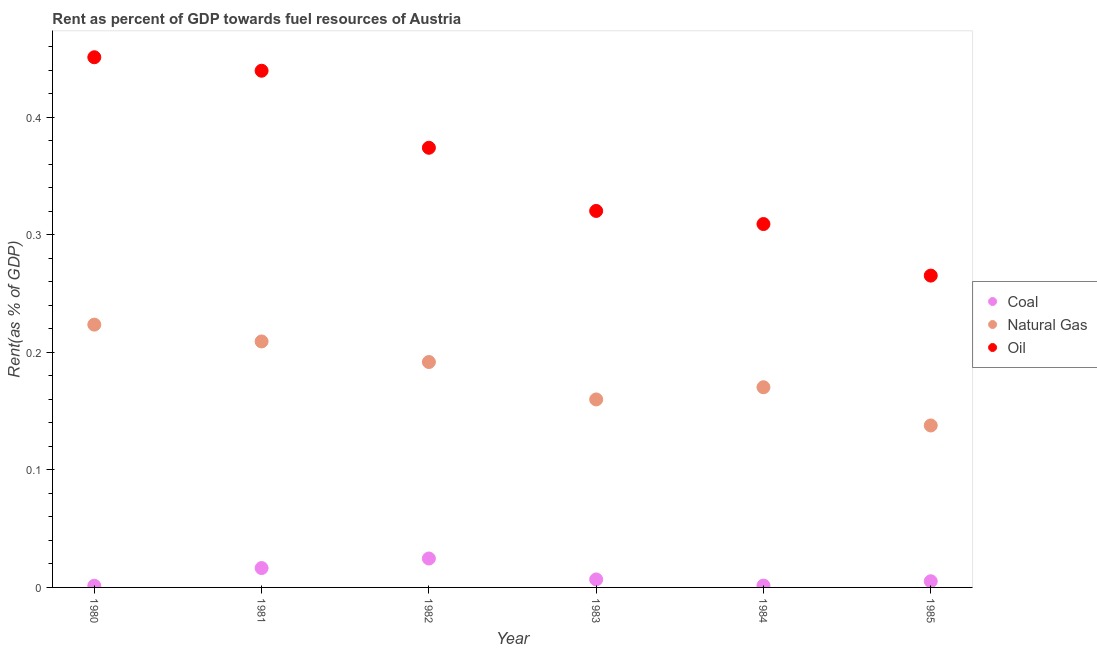How many different coloured dotlines are there?
Your answer should be compact. 3. What is the rent towards natural gas in 1981?
Make the answer very short. 0.21. Across all years, what is the maximum rent towards coal?
Offer a terse response. 0.02. Across all years, what is the minimum rent towards oil?
Your answer should be very brief. 0.27. In which year was the rent towards natural gas maximum?
Provide a succinct answer. 1980. In which year was the rent towards oil minimum?
Keep it short and to the point. 1985. What is the total rent towards oil in the graph?
Give a very brief answer. 2.16. What is the difference between the rent towards coal in 1980 and that in 1981?
Keep it short and to the point. -0.02. What is the difference between the rent towards oil in 1983 and the rent towards natural gas in 1984?
Offer a terse response. 0.15. What is the average rent towards natural gas per year?
Your response must be concise. 0.18. In the year 1985, what is the difference between the rent towards coal and rent towards natural gas?
Provide a succinct answer. -0.13. In how many years, is the rent towards coal greater than 0.1 %?
Your answer should be compact. 0. What is the ratio of the rent towards coal in 1984 to that in 1985?
Ensure brevity in your answer.  0.29. What is the difference between the highest and the second highest rent towards coal?
Your answer should be compact. 0.01. What is the difference between the highest and the lowest rent towards coal?
Make the answer very short. 0.02. In how many years, is the rent towards natural gas greater than the average rent towards natural gas taken over all years?
Your answer should be very brief. 3. Is the sum of the rent towards oil in 1980 and 1983 greater than the maximum rent towards coal across all years?
Make the answer very short. Yes. Is it the case that in every year, the sum of the rent towards coal and rent towards natural gas is greater than the rent towards oil?
Provide a short and direct response. No. Is the rent towards coal strictly greater than the rent towards oil over the years?
Provide a succinct answer. No. How many dotlines are there?
Offer a very short reply. 3. What is the difference between two consecutive major ticks on the Y-axis?
Your response must be concise. 0.1. Are the values on the major ticks of Y-axis written in scientific E-notation?
Your answer should be very brief. No. Where does the legend appear in the graph?
Make the answer very short. Center right. How are the legend labels stacked?
Your response must be concise. Vertical. What is the title of the graph?
Your answer should be compact. Rent as percent of GDP towards fuel resources of Austria. Does "Travel services" appear as one of the legend labels in the graph?
Offer a terse response. No. What is the label or title of the Y-axis?
Keep it short and to the point. Rent(as % of GDP). What is the Rent(as % of GDP) in Coal in 1980?
Make the answer very short. 0. What is the Rent(as % of GDP) in Natural Gas in 1980?
Your response must be concise. 0.22. What is the Rent(as % of GDP) of Oil in 1980?
Ensure brevity in your answer.  0.45. What is the Rent(as % of GDP) of Coal in 1981?
Keep it short and to the point. 0.02. What is the Rent(as % of GDP) in Natural Gas in 1981?
Keep it short and to the point. 0.21. What is the Rent(as % of GDP) in Oil in 1981?
Provide a succinct answer. 0.44. What is the Rent(as % of GDP) in Coal in 1982?
Your answer should be compact. 0.02. What is the Rent(as % of GDP) of Natural Gas in 1982?
Your answer should be compact. 0.19. What is the Rent(as % of GDP) in Oil in 1982?
Keep it short and to the point. 0.37. What is the Rent(as % of GDP) of Coal in 1983?
Make the answer very short. 0.01. What is the Rent(as % of GDP) in Natural Gas in 1983?
Give a very brief answer. 0.16. What is the Rent(as % of GDP) in Oil in 1983?
Provide a short and direct response. 0.32. What is the Rent(as % of GDP) of Coal in 1984?
Give a very brief answer. 0. What is the Rent(as % of GDP) in Natural Gas in 1984?
Offer a very short reply. 0.17. What is the Rent(as % of GDP) of Oil in 1984?
Keep it short and to the point. 0.31. What is the Rent(as % of GDP) in Coal in 1985?
Offer a very short reply. 0.01. What is the Rent(as % of GDP) of Natural Gas in 1985?
Make the answer very short. 0.14. What is the Rent(as % of GDP) in Oil in 1985?
Provide a short and direct response. 0.27. Across all years, what is the maximum Rent(as % of GDP) in Coal?
Provide a succinct answer. 0.02. Across all years, what is the maximum Rent(as % of GDP) in Natural Gas?
Make the answer very short. 0.22. Across all years, what is the maximum Rent(as % of GDP) in Oil?
Your answer should be very brief. 0.45. Across all years, what is the minimum Rent(as % of GDP) of Coal?
Ensure brevity in your answer.  0. Across all years, what is the minimum Rent(as % of GDP) in Natural Gas?
Your answer should be compact. 0.14. Across all years, what is the minimum Rent(as % of GDP) in Oil?
Give a very brief answer. 0.27. What is the total Rent(as % of GDP) in Coal in the graph?
Provide a succinct answer. 0.06. What is the total Rent(as % of GDP) in Natural Gas in the graph?
Your answer should be very brief. 1.09. What is the total Rent(as % of GDP) of Oil in the graph?
Keep it short and to the point. 2.16. What is the difference between the Rent(as % of GDP) in Coal in 1980 and that in 1981?
Offer a very short reply. -0.02. What is the difference between the Rent(as % of GDP) in Natural Gas in 1980 and that in 1981?
Your response must be concise. 0.01. What is the difference between the Rent(as % of GDP) of Oil in 1980 and that in 1981?
Make the answer very short. 0.01. What is the difference between the Rent(as % of GDP) of Coal in 1980 and that in 1982?
Your response must be concise. -0.02. What is the difference between the Rent(as % of GDP) of Natural Gas in 1980 and that in 1982?
Your answer should be very brief. 0.03. What is the difference between the Rent(as % of GDP) in Oil in 1980 and that in 1982?
Provide a short and direct response. 0.08. What is the difference between the Rent(as % of GDP) of Coal in 1980 and that in 1983?
Provide a succinct answer. -0.01. What is the difference between the Rent(as % of GDP) in Natural Gas in 1980 and that in 1983?
Ensure brevity in your answer.  0.06. What is the difference between the Rent(as % of GDP) of Oil in 1980 and that in 1983?
Offer a very short reply. 0.13. What is the difference between the Rent(as % of GDP) of Coal in 1980 and that in 1984?
Provide a short and direct response. -0. What is the difference between the Rent(as % of GDP) in Natural Gas in 1980 and that in 1984?
Offer a terse response. 0.05. What is the difference between the Rent(as % of GDP) in Oil in 1980 and that in 1984?
Your answer should be very brief. 0.14. What is the difference between the Rent(as % of GDP) in Coal in 1980 and that in 1985?
Offer a very short reply. -0. What is the difference between the Rent(as % of GDP) of Natural Gas in 1980 and that in 1985?
Offer a very short reply. 0.09. What is the difference between the Rent(as % of GDP) of Oil in 1980 and that in 1985?
Your response must be concise. 0.19. What is the difference between the Rent(as % of GDP) of Coal in 1981 and that in 1982?
Ensure brevity in your answer.  -0.01. What is the difference between the Rent(as % of GDP) of Natural Gas in 1981 and that in 1982?
Your answer should be very brief. 0.02. What is the difference between the Rent(as % of GDP) of Oil in 1981 and that in 1982?
Your answer should be compact. 0.07. What is the difference between the Rent(as % of GDP) of Coal in 1981 and that in 1983?
Provide a succinct answer. 0.01. What is the difference between the Rent(as % of GDP) in Natural Gas in 1981 and that in 1983?
Offer a very short reply. 0.05. What is the difference between the Rent(as % of GDP) of Oil in 1981 and that in 1983?
Make the answer very short. 0.12. What is the difference between the Rent(as % of GDP) of Coal in 1981 and that in 1984?
Your response must be concise. 0.01. What is the difference between the Rent(as % of GDP) of Natural Gas in 1981 and that in 1984?
Ensure brevity in your answer.  0.04. What is the difference between the Rent(as % of GDP) in Oil in 1981 and that in 1984?
Offer a very short reply. 0.13. What is the difference between the Rent(as % of GDP) of Coal in 1981 and that in 1985?
Your answer should be compact. 0.01. What is the difference between the Rent(as % of GDP) in Natural Gas in 1981 and that in 1985?
Keep it short and to the point. 0.07. What is the difference between the Rent(as % of GDP) in Oil in 1981 and that in 1985?
Provide a succinct answer. 0.17. What is the difference between the Rent(as % of GDP) in Coal in 1982 and that in 1983?
Ensure brevity in your answer.  0.02. What is the difference between the Rent(as % of GDP) in Natural Gas in 1982 and that in 1983?
Ensure brevity in your answer.  0.03. What is the difference between the Rent(as % of GDP) of Oil in 1982 and that in 1983?
Offer a terse response. 0.05. What is the difference between the Rent(as % of GDP) of Coal in 1982 and that in 1984?
Offer a terse response. 0.02. What is the difference between the Rent(as % of GDP) of Natural Gas in 1982 and that in 1984?
Provide a short and direct response. 0.02. What is the difference between the Rent(as % of GDP) of Oil in 1982 and that in 1984?
Offer a terse response. 0.06. What is the difference between the Rent(as % of GDP) in Coal in 1982 and that in 1985?
Your answer should be compact. 0.02. What is the difference between the Rent(as % of GDP) in Natural Gas in 1982 and that in 1985?
Your answer should be very brief. 0.05. What is the difference between the Rent(as % of GDP) of Oil in 1982 and that in 1985?
Make the answer very short. 0.11. What is the difference between the Rent(as % of GDP) in Coal in 1983 and that in 1984?
Provide a short and direct response. 0.01. What is the difference between the Rent(as % of GDP) of Natural Gas in 1983 and that in 1984?
Keep it short and to the point. -0.01. What is the difference between the Rent(as % of GDP) in Oil in 1983 and that in 1984?
Give a very brief answer. 0.01. What is the difference between the Rent(as % of GDP) in Coal in 1983 and that in 1985?
Your answer should be very brief. 0. What is the difference between the Rent(as % of GDP) in Natural Gas in 1983 and that in 1985?
Your answer should be compact. 0.02. What is the difference between the Rent(as % of GDP) in Oil in 1983 and that in 1985?
Ensure brevity in your answer.  0.06. What is the difference between the Rent(as % of GDP) of Coal in 1984 and that in 1985?
Your response must be concise. -0. What is the difference between the Rent(as % of GDP) in Natural Gas in 1984 and that in 1985?
Your answer should be very brief. 0.03. What is the difference between the Rent(as % of GDP) in Oil in 1984 and that in 1985?
Your answer should be very brief. 0.04. What is the difference between the Rent(as % of GDP) in Coal in 1980 and the Rent(as % of GDP) in Natural Gas in 1981?
Provide a succinct answer. -0.21. What is the difference between the Rent(as % of GDP) in Coal in 1980 and the Rent(as % of GDP) in Oil in 1981?
Provide a short and direct response. -0.44. What is the difference between the Rent(as % of GDP) in Natural Gas in 1980 and the Rent(as % of GDP) in Oil in 1981?
Your answer should be very brief. -0.22. What is the difference between the Rent(as % of GDP) of Coal in 1980 and the Rent(as % of GDP) of Natural Gas in 1982?
Provide a short and direct response. -0.19. What is the difference between the Rent(as % of GDP) in Coal in 1980 and the Rent(as % of GDP) in Oil in 1982?
Offer a terse response. -0.37. What is the difference between the Rent(as % of GDP) in Natural Gas in 1980 and the Rent(as % of GDP) in Oil in 1982?
Your answer should be very brief. -0.15. What is the difference between the Rent(as % of GDP) of Coal in 1980 and the Rent(as % of GDP) of Natural Gas in 1983?
Offer a very short reply. -0.16. What is the difference between the Rent(as % of GDP) of Coal in 1980 and the Rent(as % of GDP) of Oil in 1983?
Ensure brevity in your answer.  -0.32. What is the difference between the Rent(as % of GDP) of Natural Gas in 1980 and the Rent(as % of GDP) of Oil in 1983?
Provide a succinct answer. -0.1. What is the difference between the Rent(as % of GDP) of Coal in 1980 and the Rent(as % of GDP) of Natural Gas in 1984?
Your answer should be compact. -0.17. What is the difference between the Rent(as % of GDP) of Coal in 1980 and the Rent(as % of GDP) of Oil in 1984?
Ensure brevity in your answer.  -0.31. What is the difference between the Rent(as % of GDP) in Natural Gas in 1980 and the Rent(as % of GDP) in Oil in 1984?
Provide a short and direct response. -0.09. What is the difference between the Rent(as % of GDP) of Coal in 1980 and the Rent(as % of GDP) of Natural Gas in 1985?
Provide a succinct answer. -0.14. What is the difference between the Rent(as % of GDP) in Coal in 1980 and the Rent(as % of GDP) in Oil in 1985?
Your response must be concise. -0.26. What is the difference between the Rent(as % of GDP) of Natural Gas in 1980 and the Rent(as % of GDP) of Oil in 1985?
Offer a terse response. -0.04. What is the difference between the Rent(as % of GDP) in Coal in 1981 and the Rent(as % of GDP) in Natural Gas in 1982?
Give a very brief answer. -0.18. What is the difference between the Rent(as % of GDP) of Coal in 1981 and the Rent(as % of GDP) of Oil in 1982?
Keep it short and to the point. -0.36. What is the difference between the Rent(as % of GDP) of Natural Gas in 1981 and the Rent(as % of GDP) of Oil in 1982?
Your response must be concise. -0.16. What is the difference between the Rent(as % of GDP) in Coal in 1981 and the Rent(as % of GDP) in Natural Gas in 1983?
Provide a short and direct response. -0.14. What is the difference between the Rent(as % of GDP) in Coal in 1981 and the Rent(as % of GDP) in Oil in 1983?
Offer a terse response. -0.3. What is the difference between the Rent(as % of GDP) in Natural Gas in 1981 and the Rent(as % of GDP) in Oil in 1983?
Provide a short and direct response. -0.11. What is the difference between the Rent(as % of GDP) in Coal in 1981 and the Rent(as % of GDP) in Natural Gas in 1984?
Your answer should be compact. -0.15. What is the difference between the Rent(as % of GDP) in Coal in 1981 and the Rent(as % of GDP) in Oil in 1984?
Ensure brevity in your answer.  -0.29. What is the difference between the Rent(as % of GDP) of Natural Gas in 1981 and the Rent(as % of GDP) of Oil in 1984?
Your answer should be compact. -0.1. What is the difference between the Rent(as % of GDP) of Coal in 1981 and the Rent(as % of GDP) of Natural Gas in 1985?
Give a very brief answer. -0.12. What is the difference between the Rent(as % of GDP) of Coal in 1981 and the Rent(as % of GDP) of Oil in 1985?
Ensure brevity in your answer.  -0.25. What is the difference between the Rent(as % of GDP) of Natural Gas in 1981 and the Rent(as % of GDP) of Oil in 1985?
Make the answer very short. -0.06. What is the difference between the Rent(as % of GDP) in Coal in 1982 and the Rent(as % of GDP) in Natural Gas in 1983?
Provide a succinct answer. -0.14. What is the difference between the Rent(as % of GDP) in Coal in 1982 and the Rent(as % of GDP) in Oil in 1983?
Offer a terse response. -0.3. What is the difference between the Rent(as % of GDP) of Natural Gas in 1982 and the Rent(as % of GDP) of Oil in 1983?
Your response must be concise. -0.13. What is the difference between the Rent(as % of GDP) of Coal in 1982 and the Rent(as % of GDP) of Natural Gas in 1984?
Offer a very short reply. -0.15. What is the difference between the Rent(as % of GDP) in Coal in 1982 and the Rent(as % of GDP) in Oil in 1984?
Make the answer very short. -0.28. What is the difference between the Rent(as % of GDP) of Natural Gas in 1982 and the Rent(as % of GDP) of Oil in 1984?
Offer a terse response. -0.12. What is the difference between the Rent(as % of GDP) of Coal in 1982 and the Rent(as % of GDP) of Natural Gas in 1985?
Offer a terse response. -0.11. What is the difference between the Rent(as % of GDP) of Coal in 1982 and the Rent(as % of GDP) of Oil in 1985?
Give a very brief answer. -0.24. What is the difference between the Rent(as % of GDP) of Natural Gas in 1982 and the Rent(as % of GDP) of Oil in 1985?
Make the answer very short. -0.07. What is the difference between the Rent(as % of GDP) in Coal in 1983 and the Rent(as % of GDP) in Natural Gas in 1984?
Your answer should be compact. -0.16. What is the difference between the Rent(as % of GDP) of Coal in 1983 and the Rent(as % of GDP) of Oil in 1984?
Offer a very short reply. -0.3. What is the difference between the Rent(as % of GDP) of Natural Gas in 1983 and the Rent(as % of GDP) of Oil in 1984?
Give a very brief answer. -0.15. What is the difference between the Rent(as % of GDP) of Coal in 1983 and the Rent(as % of GDP) of Natural Gas in 1985?
Your answer should be very brief. -0.13. What is the difference between the Rent(as % of GDP) of Coal in 1983 and the Rent(as % of GDP) of Oil in 1985?
Your response must be concise. -0.26. What is the difference between the Rent(as % of GDP) in Natural Gas in 1983 and the Rent(as % of GDP) in Oil in 1985?
Ensure brevity in your answer.  -0.11. What is the difference between the Rent(as % of GDP) in Coal in 1984 and the Rent(as % of GDP) in Natural Gas in 1985?
Provide a short and direct response. -0.14. What is the difference between the Rent(as % of GDP) of Coal in 1984 and the Rent(as % of GDP) of Oil in 1985?
Your answer should be compact. -0.26. What is the difference between the Rent(as % of GDP) in Natural Gas in 1984 and the Rent(as % of GDP) in Oil in 1985?
Make the answer very short. -0.1. What is the average Rent(as % of GDP) of Coal per year?
Offer a terse response. 0.01. What is the average Rent(as % of GDP) of Natural Gas per year?
Offer a very short reply. 0.18. What is the average Rent(as % of GDP) in Oil per year?
Offer a terse response. 0.36. In the year 1980, what is the difference between the Rent(as % of GDP) in Coal and Rent(as % of GDP) in Natural Gas?
Your answer should be very brief. -0.22. In the year 1980, what is the difference between the Rent(as % of GDP) of Coal and Rent(as % of GDP) of Oil?
Give a very brief answer. -0.45. In the year 1980, what is the difference between the Rent(as % of GDP) of Natural Gas and Rent(as % of GDP) of Oil?
Provide a succinct answer. -0.23. In the year 1981, what is the difference between the Rent(as % of GDP) in Coal and Rent(as % of GDP) in Natural Gas?
Your answer should be compact. -0.19. In the year 1981, what is the difference between the Rent(as % of GDP) in Coal and Rent(as % of GDP) in Oil?
Give a very brief answer. -0.42. In the year 1981, what is the difference between the Rent(as % of GDP) in Natural Gas and Rent(as % of GDP) in Oil?
Keep it short and to the point. -0.23. In the year 1982, what is the difference between the Rent(as % of GDP) in Coal and Rent(as % of GDP) in Natural Gas?
Provide a short and direct response. -0.17. In the year 1982, what is the difference between the Rent(as % of GDP) of Coal and Rent(as % of GDP) of Oil?
Offer a very short reply. -0.35. In the year 1982, what is the difference between the Rent(as % of GDP) in Natural Gas and Rent(as % of GDP) in Oil?
Keep it short and to the point. -0.18. In the year 1983, what is the difference between the Rent(as % of GDP) of Coal and Rent(as % of GDP) of Natural Gas?
Ensure brevity in your answer.  -0.15. In the year 1983, what is the difference between the Rent(as % of GDP) of Coal and Rent(as % of GDP) of Oil?
Your response must be concise. -0.31. In the year 1983, what is the difference between the Rent(as % of GDP) of Natural Gas and Rent(as % of GDP) of Oil?
Your answer should be very brief. -0.16. In the year 1984, what is the difference between the Rent(as % of GDP) of Coal and Rent(as % of GDP) of Natural Gas?
Your response must be concise. -0.17. In the year 1984, what is the difference between the Rent(as % of GDP) in Coal and Rent(as % of GDP) in Oil?
Provide a succinct answer. -0.31. In the year 1984, what is the difference between the Rent(as % of GDP) in Natural Gas and Rent(as % of GDP) in Oil?
Provide a short and direct response. -0.14. In the year 1985, what is the difference between the Rent(as % of GDP) of Coal and Rent(as % of GDP) of Natural Gas?
Offer a very short reply. -0.13. In the year 1985, what is the difference between the Rent(as % of GDP) in Coal and Rent(as % of GDP) in Oil?
Your answer should be very brief. -0.26. In the year 1985, what is the difference between the Rent(as % of GDP) in Natural Gas and Rent(as % of GDP) in Oil?
Keep it short and to the point. -0.13. What is the ratio of the Rent(as % of GDP) of Coal in 1980 to that in 1981?
Provide a short and direct response. 0.09. What is the ratio of the Rent(as % of GDP) in Natural Gas in 1980 to that in 1981?
Give a very brief answer. 1.07. What is the ratio of the Rent(as % of GDP) of Oil in 1980 to that in 1981?
Your answer should be compact. 1.03. What is the ratio of the Rent(as % of GDP) of Coal in 1980 to that in 1982?
Offer a very short reply. 0.06. What is the ratio of the Rent(as % of GDP) of Natural Gas in 1980 to that in 1982?
Offer a very short reply. 1.17. What is the ratio of the Rent(as % of GDP) of Oil in 1980 to that in 1982?
Provide a short and direct response. 1.21. What is the ratio of the Rent(as % of GDP) in Coal in 1980 to that in 1983?
Make the answer very short. 0.21. What is the ratio of the Rent(as % of GDP) of Natural Gas in 1980 to that in 1983?
Offer a very short reply. 1.4. What is the ratio of the Rent(as % of GDP) of Oil in 1980 to that in 1983?
Offer a terse response. 1.41. What is the ratio of the Rent(as % of GDP) in Coal in 1980 to that in 1984?
Give a very brief answer. 0.91. What is the ratio of the Rent(as % of GDP) of Natural Gas in 1980 to that in 1984?
Make the answer very short. 1.31. What is the ratio of the Rent(as % of GDP) in Oil in 1980 to that in 1984?
Make the answer very short. 1.46. What is the ratio of the Rent(as % of GDP) in Coal in 1980 to that in 1985?
Provide a short and direct response. 0.27. What is the ratio of the Rent(as % of GDP) in Natural Gas in 1980 to that in 1985?
Your answer should be compact. 1.62. What is the ratio of the Rent(as % of GDP) of Oil in 1980 to that in 1985?
Ensure brevity in your answer.  1.7. What is the ratio of the Rent(as % of GDP) of Coal in 1981 to that in 1982?
Ensure brevity in your answer.  0.67. What is the ratio of the Rent(as % of GDP) in Natural Gas in 1981 to that in 1982?
Your response must be concise. 1.09. What is the ratio of the Rent(as % of GDP) in Oil in 1981 to that in 1982?
Your answer should be very brief. 1.18. What is the ratio of the Rent(as % of GDP) of Coal in 1981 to that in 1983?
Your response must be concise. 2.42. What is the ratio of the Rent(as % of GDP) in Natural Gas in 1981 to that in 1983?
Keep it short and to the point. 1.31. What is the ratio of the Rent(as % of GDP) in Oil in 1981 to that in 1983?
Give a very brief answer. 1.37. What is the ratio of the Rent(as % of GDP) in Coal in 1981 to that in 1984?
Your answer should be very brief. 10.69. What is the ratio of the Rent(as % of GDP) of Natural Gas in 1981 to that in 1984?
Your answer should be very brief. 1.23. What is the ratio of the Rent(as % of GDP) in Oil in 1981 to that in 1984?
Offer a terse response. 1.42. What is the ratio of the Rent(as % of GDP) of Coal in 1981 to that in 1985?
Offer a terse response. 3.13. What is the ratio of the Rent(as % of GDP) in Natural Gas in 1981 to that in 1985?
Provide a short and direct response. 1.52. What is the ratio of the Rent(as % of GDP) in Oil in 1981 to that in 1985?
Keep it short and to the point. 1.66. What is the ratio of the Rent(as % of GDP) of Coal in 1982 to that in 1983?
Make the answer very short. 3.62. What is the ratio of the Rent(as % of GDP) in Natural Gas in 1982 to that in 1983?
Offer a very short reply. 1.2. What is the ratio of the Rent(as % of GDP) of Oil in 1982 to that in 1983?
Your answer should be very brief. 1.17. What is the ratio of the Rent(as % of GDP) of Coal in 1982 to that in 1984?
Give a very brief answer. 15.97. What is the ratio of the Rent(as % of GDP) in Natural Gas in 1982 to that in 1984?
Give a very brief answer. 1.13. What is the ratio of the Rent(as % of GDP) in Oil in 1982 to that in 1984?
Provide a succinct answer. 1.21. What is the ratio of the Rent(as % of GDP) of Coal in 1982 to that in 1985?
Provide a short and direct response. 4.68. What is the ratio of the Rent(as % of GDP) in Natural Gas in 1982 to that in 1985?
Provide a short and direct response. 1.39. What is the ratio of the Rent(as % of GDP) in Oil in 1982 to that in 1985?
Offer a terse response. 1.41. What is the ratio of the Rent(as % of GDP) of Coal in 1983 to that in 1984?
Your response must be concise. 4.42. What is the ratio of the Rent(as % of GDP) of Natural Gas in 1983 to that in 1984?
Ensure brevity in your answer.  0.94. What is the ratio of the Rent(as % of GDP) of Oil in 1983 to that in 1984?
Provide a short and direct response. 1.04. What is the ratio of the Rent(as % of GDP) of Coal in 1983 to that in 1985?
Offer a terse response. 1.29. What is the ratio of the Rent(as % of GDP) of Natural Gas in 1983 to that in 1985?
Give a very brief answer. 1.16. What is the ratio of the Rent(as % of GDP) in Oil in 1983 to that in 1985?
Your response must be concise. 1.21. What is the ratio of the Rent(as % of GDP) of Coal in 1984 to that in 1985?
Provide a short and direct response. 0.29. What is the ratio of the Rent(as % of GDP) in Natural Gas in 1984 to that in 1985?
Ensure brevity in your answer.  1.24. What is the ratio of the Rent(as % of GDP) of Oil in 1984 to that in 1985?
Keep it short and to the point. 1.17. What is the difference between the highest and the second highest Rent(as % of GDP) of Coal?
Your answer should be compact. 0.01. What is the difference between the highest and the second highest Rent(as % of GDP) of Natural Gas?
Your answer should be very brief. 0.01. What is the difference between the highest and the second highest Rent(as % of GDP) in Oil?
Your answer should be compact. 0.01. What is the difference between the highest and the lowest Rent(as % of GDP) in Coal?
Your response must be concise. 0.02. What is the difference between the highest and the lowest Rent(as % of GDP) of Natural Gas?
Your answer should be very brief. 0.09. What is the difference between the highest and the lowest Rent(as % of GDP) in Oil?
Provide a short and direct response. 0.19. 